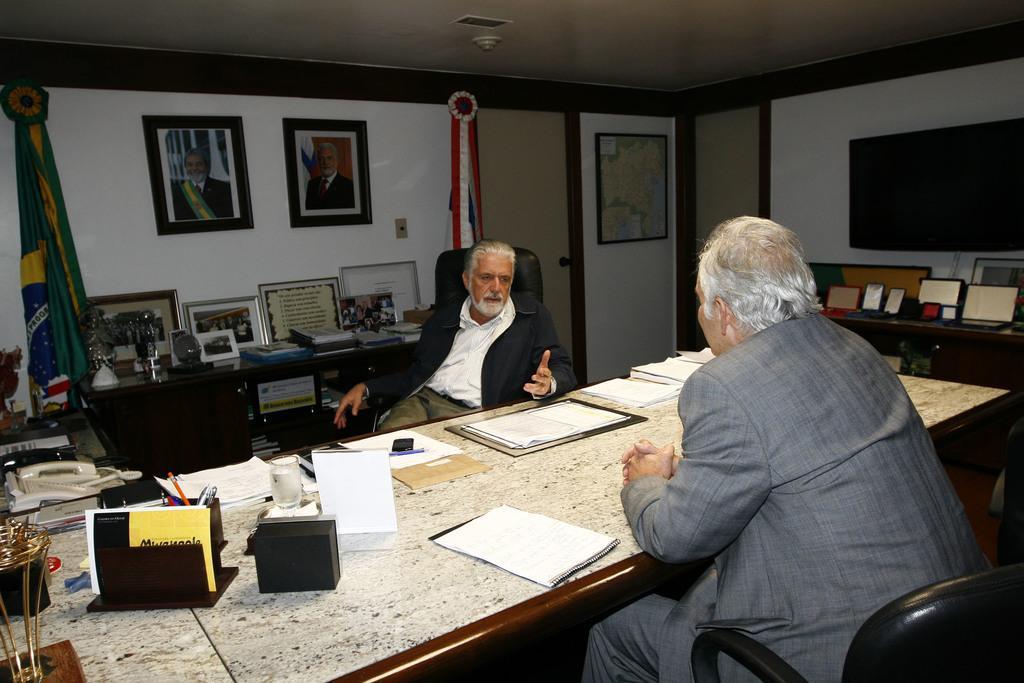How would you summarize this image in a sentence or two? In this picture we can see two persons sitting on chairs in front of a table, there are some papers, a file, a pen stand, a board, a telephone and some other things present on the table, in the background there is a wall, we can see photo frames on the wall, there is a flag here, we can see some books here, on the right side there is a screen, we can see the ceiling at the top of the picture. 